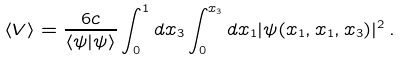<formula> <loc_0><loc_0><loc_500><loc_500>\langle V \rangle = \frac { 6 c } { \langle \psi | \psi \rangle } \int _ { 0 } ^ { 1 } d x _ { 3 } \int _ { 0 } ^ { x _ { 3 } } d x _ { 1 } | \psi ( x _ { 1 } , x _ { 1 } , x _ { 3 } ) | ^ { 2 } \, .</formula> 